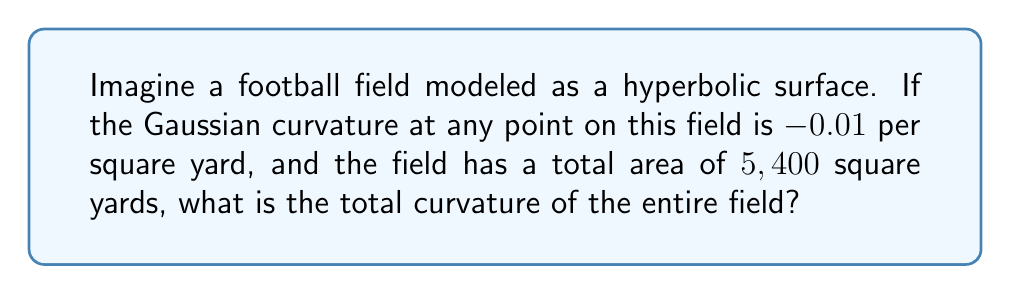Provide a solution to this math problem. Let's approach this step-by-step:

1) In hyperbolic geometry, the Gaussian curvature (K) is constant and negative. Here, K = -0.01 per square yard.

2) The total area of the field is given as 5,400 square yards.

3) To find the total curvature, we need to use the Gauss-Bonnet theorem. For a closed surface without boundary, this theorem states:

   $$\int\int_S K dA = 2\pi\chi(S)$$

   where $\chi(S)$ is the Euler characteristic of the surface.

4) However, our football field is not a closed surface. For an open surface, the theorem becomes:

   $$\int\int_S K dA = 2\pi\chi(S) - \int_{\partial S} k_g ds$$

   where $\int_{\partial S} k_g ds$ is the integral of the geodesic curvature along the boundary.

5) For our purposes, we can ignore the boundary term and focus on the surface integral:

   $$\int\int_S K dA$$

6) Since K is constant over the entire surface, we can simplify this to:

   $$K \cdot A$$

   where A is the total area of the surface.

7) Substituting our values:

   Total Curvature = -0.01 * 5,400 = -54

Therefore, the total curvature of the entire field is -54.
Answer: -54 